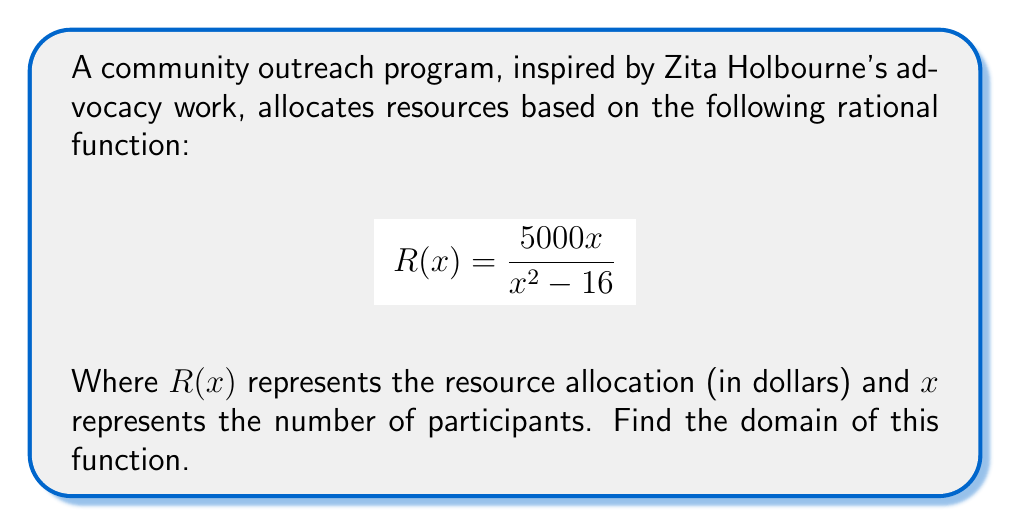Can you solve this math problem? To find the domain of a rational function, we need to determine all real values of x for which the function is defined. The function will be undefined when its denominator equals zero.

Step 1: Set the denominator equal to zero and solve for x.
$$x^2 - 16 = 0$$
$$x^2 = 16$$
$$x = \pm 4$$

Step 2: The function will be undefined when x = 4 or x = -4. These values must be excluded from the domain.

Step 3: Express the domain using interval notation. The domain will include all real numbers except for 4 and -4.

Therefore, the domain is: $(-\infty, -4) \cup (-4, 4) \cup (4, \infty)$

This means the resource allocation function is defined for any number of participants except exactly 4 or -4. (Note: While negative participants don't make practical sense, we include them in the mathematical domain.)
Answer: $(-\infty, -4) \cup (-4, 4) \cup (4, \infty)$ 